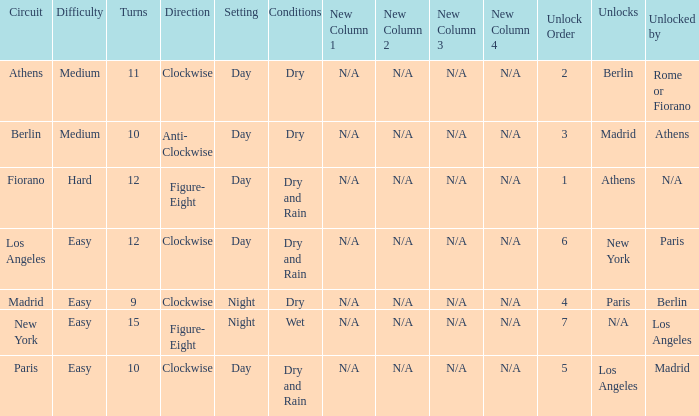What is the lowest unlock order for the athens circuit? 2.0. 